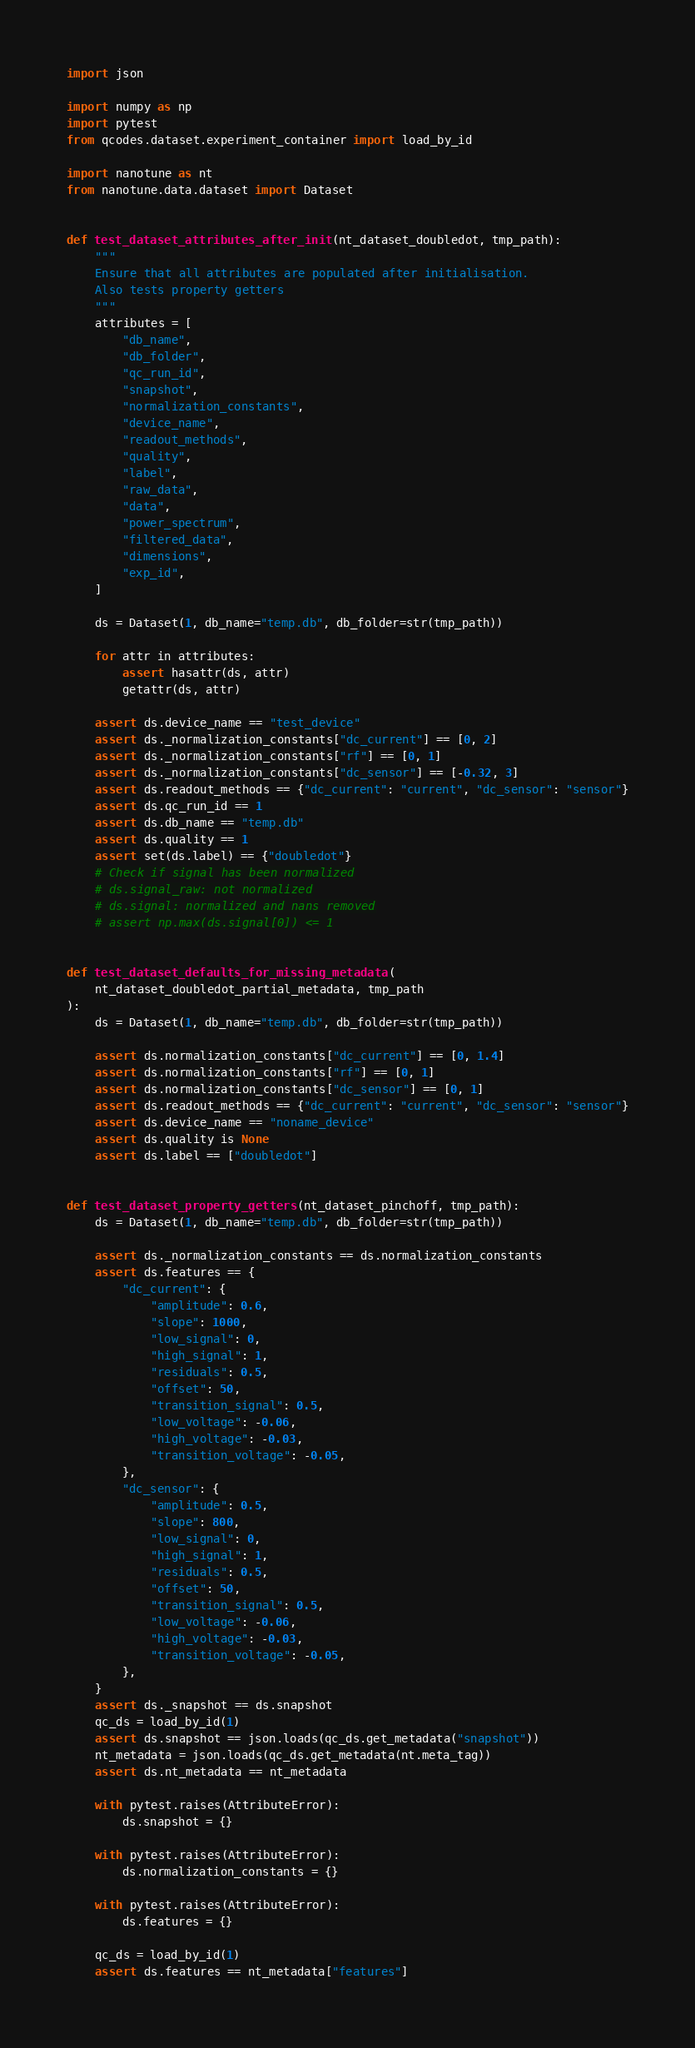Convert code to text. <code><loc_0><loc_0><loc_500><loc_500><_Python_>import json

import numpy as np
import pytest
from qcodes.dataset.experiment_container import load_by_id

import nanotune as nt
from nanotune.data.dataset import Dataset


def test_dataset_attributes_after_init(nt_dataset_doubledot, tmp_path):
    """
    Ensure that all attributes are populated after initialisation.
    Also tests property getters
    """
    attributes = [
        "db_name",
        "db_folder",
        "qc_run_id",
        "snapshot",
        "normalization_constants",
        "device_name",
        "readout_methods",
        "quality",
        "label",
        "raw_data",
        "data",
        "power_spectrum",
        "filtered_data",
        "dimensions",
        "exp_id",
    ]

    ds = Dataset(1, db_name="temp.db", db_folder=str(tmp_path))

    for attr in attributes:
        assert hasattr(ds, attr)
        getattr(ds, attr)

    assert ds.device_name == "test_device"
    assert ds._normalization_constants["dc_current"] == [0, 2]
    assert ds._normalization_constants["rf"] == [0, 1]
    assert ds._normalization_constants["dc_sensor"] == [-0.32, 3]
    assert ds.readout_methods == {"dc_current": "current", "dc_sensor": "sensor"}
    assert ds.qc_run_id == 1
    assert ds.db_name == "temp.db"
    assert ds.quality == 1
    assert set(ds.label) == {"doubledot"}
    # Check if signal has been normalized
    # ds.signal_raw: not normalized
    # ds.signal: normalized and nans removed
    # assert np.max(ds.signal[0]) <= 1


def test_dataset_defaults_for_missing_metadata(
    nt_dataset_doubledot_partial_metadata, tmp_path
):
    ds = Dataset(1, db_name="temp.db", db_folder=str(tmp_path))

    assert ds.normalization_constants["dc_current"] == [0, 1.4]
    assert ds.normalization_constants["rf"] == [0, 1]
    assert ds.normalization_constants["dc_sensor"] == [0, 1]
    assert ds.readout_methods == {"dc_current": "current", "dc_sensor": "sensor"}
    assert ds.device_name == "noname_device"
    assert ds.quality is None
    assert ds.label == ["doubledot"]


def test_dataset_property_getters(nt_dataset_pinchoff, tmp_path):
    ds = Dataset(1, db_name="temp.db", db_folder=str(tmp_path))

    assert ds._normalization_constants == ds.normalization_constants
    assert ds.features == {
        "dc_current": {
            "amplitude": 0.6,
            "slope": 1000,
            "low_signal": 0,
            "high_signal": 1,
            "residuals": 0.5,
            "offset": 50,
            "transition_signal": 0.5,
            "low_voltage": -0.06,
            "high_voltage": -0.03,
            "transition_voltage": -0.05,
        },
        "dc_sensor": {
            "amplitude": 0.5,
            "slope": 800,
            "low_signal": 0,
            "high_signal": 1,
            "residuals": 0.5,
            "offset": 50,
            "transition_signal": 0.5,
            "low_voltage": -0.06,
            "high_voltage": -0.03,
            "transition_voltage": -0.05,
        },
    }
    assert ds._snapshot == ds.snapshot
    qc_ds = load_by_id(1)
    assert ds.snapshot == json.loads(qc_ds.get_metadata("snapshot"))
    nt_metadata = json.loads(qc_ds.get_metadata(nt.meta_tag))
    assert ds.nt_metadata == nt_metadata

    with pytest.raises(AttributeError):
        ds.snapshot = {}

    with pytest.raises(AttributeError):
        ds.normalization_constants = {}

    with pytest.raises(AttributeError):
        ds.features = {}

    qc_ds = load_by_id(1)
    assert ds.features == nt_metadata["features"]
</code> 